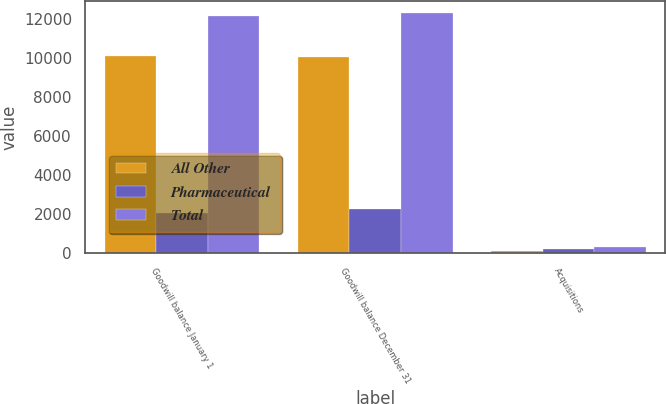Convert chart to OTSL. <chart><loc_0><loc_0><loc_500><loc_500><stacked_bar_chart><ecel><fcel>Goodwill balance January 1<fcel>Goodwill balance December 31<fcel>Acquisitions<nl><fcel>All Other<fcel>10107<fcel>10065<fcel>103<nl><fcel>Pharmaceutical<fcel>2048<fcel>2236<fcel>188<nl><fcel>Total<fcel>12155<fcel>12301<fcel>291<nl></chart> 